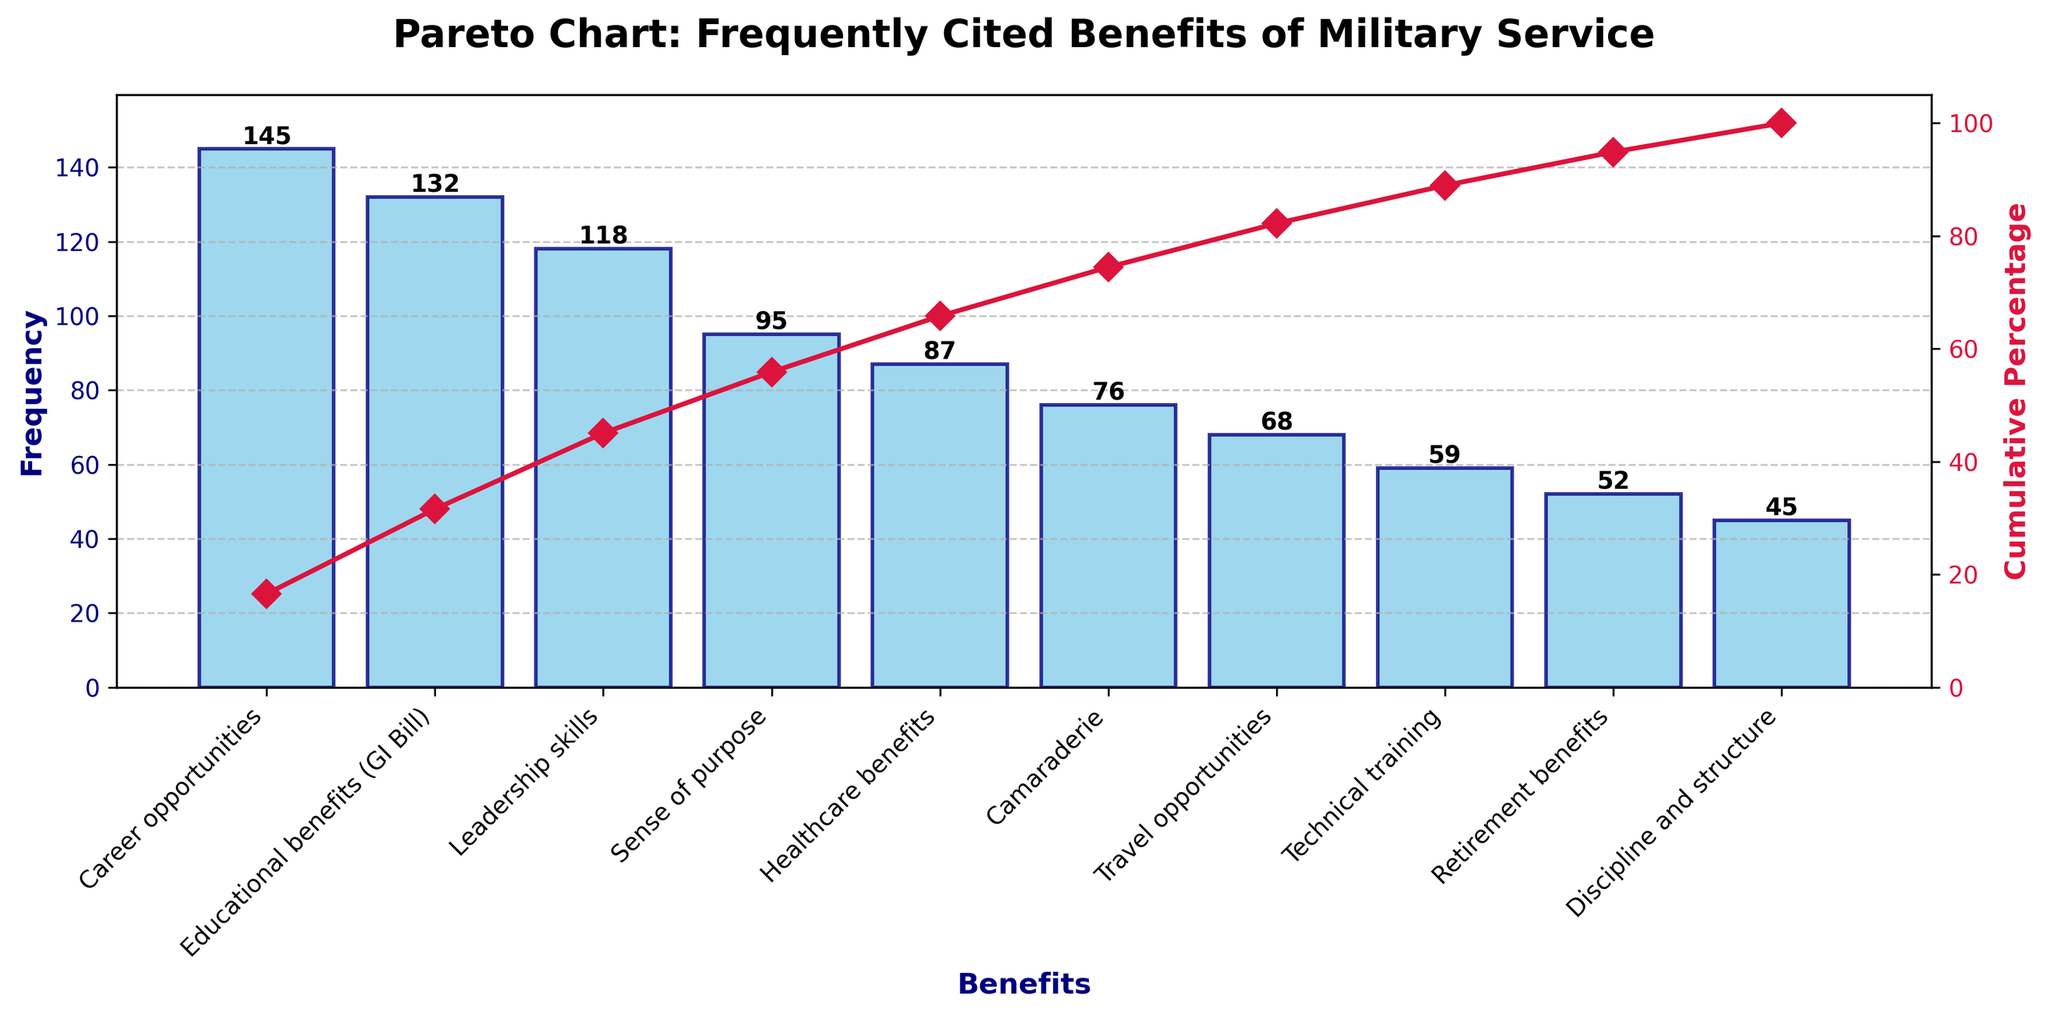What is the title of the chart? The title is the text displayed prominently at the top of the chart. It provides a summary of what the chart is about.
Answer: Pareto Chart: Frequently Cited Benefits of Military Service How many benefits are displayed in the chart? Count the number of bars or the items listed along the x-axis to determine how many benefits are shown.
Answer: 10 Which benefit has the highest frequency, and what is its value? Identify the tallest bar in the bar chart, which represents the benefit with the highest frequency. The label on this bar gives its value.
Answer: Career opportunities, 145 What is the cumulative percentage associated with ‘Leadership skills’? Locate the point on the cumulative percentage line corresponding to 'Leadership skills' on the x-axis. Read the value on the right y-axis.
Answer: Approximately 63% Which benefit reaches the cumulative percentage closest to 100%? Locate the rightmost point on the cumulative percentage line, which should be closest to 100%.
Answer: Discipline and structure What is the color of the bars, and what is the color of the cumulative percentage line? Describe the colors used in the chart's bar and line components based on visual observation.
Answer: The bars are sky blue, and the line is crimson How many benefits have a frequency greater than 100? Count the number of bars that have heights exceeding the 100 mark on the left y-axis.
Answer: 2 What cumulative percentage is achieved by the top 3 most cited benefits? Identify the cumulative percentage value after the top 3 benefits by following the cumulative line after the third benefit on the x-axis.
Answer: Approximately 75% Are healthcare benefits cited more frequently than camaraderie? Compare the heights of the bars for 'Healthcare benefits' and 'Camaraderie' to determine which one is taller.
Answer: Yes 